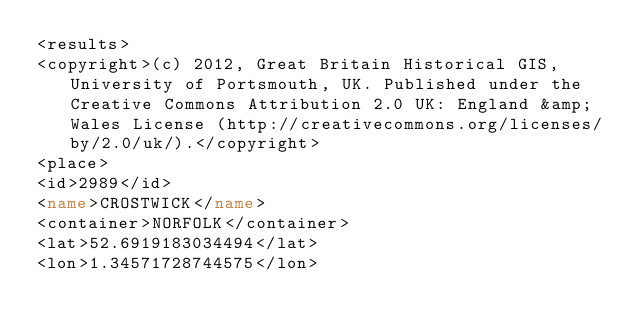Convert code to text. <code><loc_0><loc_0><loc_500><loc_500><_XML_><results>
<copyright>(c) 2012, Great Britain Historical GIS, University of Portsmouth, UK. Published under the Creative Commons Attribution 2.0 UK: England &amp; Wales License (http://creativecommons.org/licenses/by/2.0/uk/).</copyright>
<place>
<id>2989</id>
<name>CROSTWICK</name>
<container>NORFOLK</container>
<lat>52.6919183034494</lat>
<lon>1.34571728744575</lon></code> 